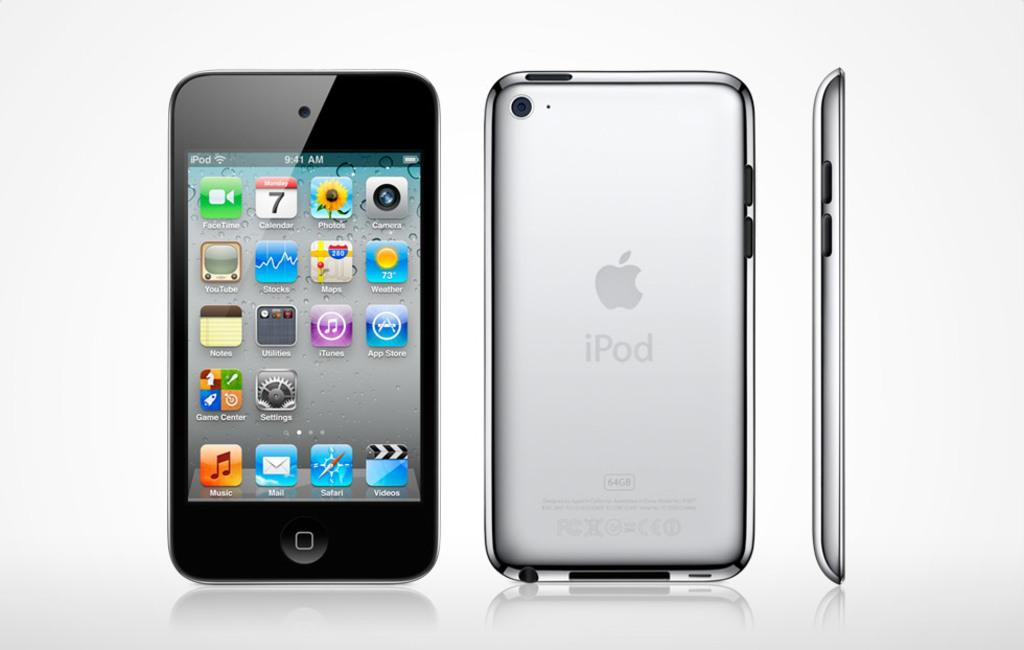<image>
Write a terse but informative summary of the picture. iPod homescreen with a host of apps such as face time and photos. 